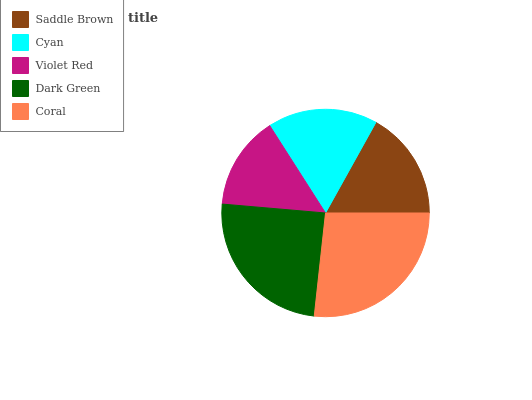Is Violet Red the minimum?
Answer yes or no. Yes. Is Coral the maximum?
Answer yes or no. Yes. Is Cyan the minimum?
Answer yes or no. No. Is Cyan the maximum?
Answer yes or no. No. Is Cyan greater than Saddle Brown?
Answer yes or no. Yes. Is Saddle Brown less than Cyan?
Answer yes or no. Yes. Is Saddle Brown greater than Cyan?
Answer yes or no. No. Is Cyan less than Saddle Brown?
Answer yes or no. No. Is Cyan the high median?
Answer yes or no. Yes. Is Cyan the low median?
Answer yes or no. Yes. Is Saddle Brown the high median?
Answer yes or no. No. Is Saddle Brown the low median?
Answer yes or no. No. 